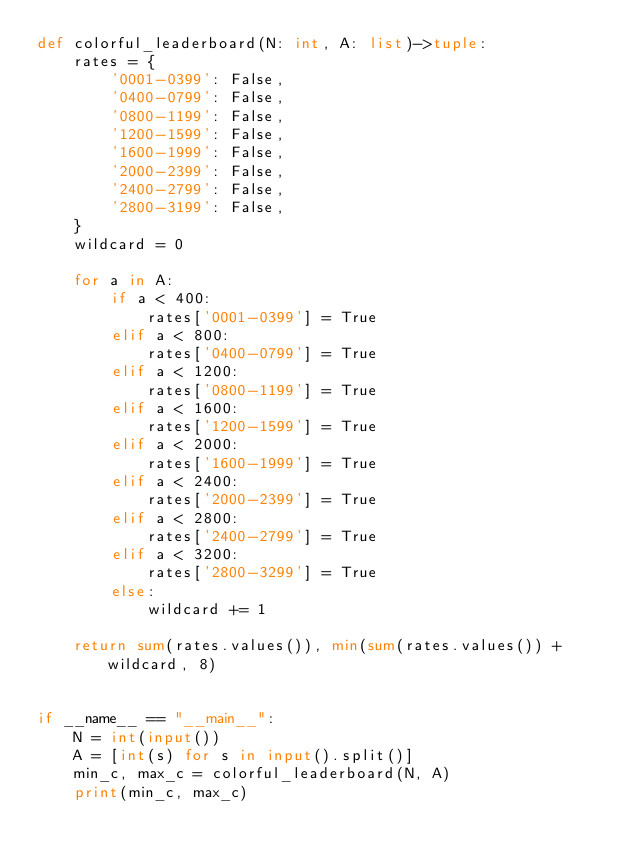<code> <loc_0><loc_0><loc_500><loc_500><_Python_>def colorful_leaderboard(N: int, A: list)->tuple:
    rates = {
        '0001-0399': False,
        '0400-0799': False,
        '0800-1199': False,
        '1200-1599': False,
        '1600-1999': False,
        '2000-2399': False,
        '2400-2799': False,
        '2800-3199': False,
    }
    wildcard = 0

    for a in A:
        if a < 400:
            rates['0001-0399'] = True
        elif a < 800:
            rates['0400-0799'] = True
        elif a < 1200:
            rates['0800-1199'] = True
        elif a < 1600:
            rates['1200-1599'] = True
        elif a < 2000:
            rates['1600-1999'] = True
        elif a < 2400:
            rates['2000-2399'] = True
        elif a < 2800:
            rates['2400-2799'] = True
        elif a < 3200:
            rates['2800-3299'] = True
        else:
            wildcard += 1

    return sum(rates.values()), min(sum(rates.values()) + wildcard, 8)


if __name__ == "__main__":
    N = int(input())
    A = [int(s) for s in input().split()]
    min_c, max_c = colorful_leaderboard(N, A)
    print(min_c, max_c)
</code> 